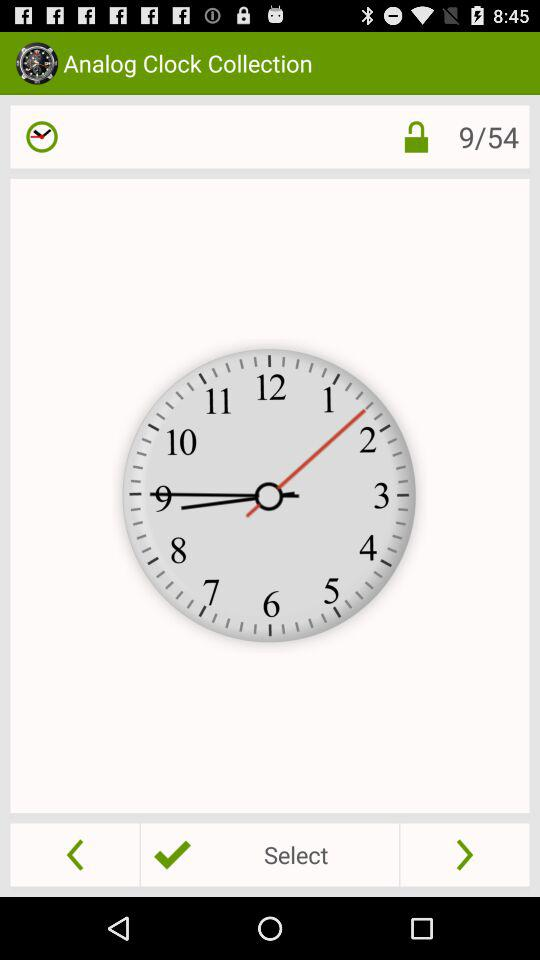What is the application name? The application name is "Analog Clock Collection". 